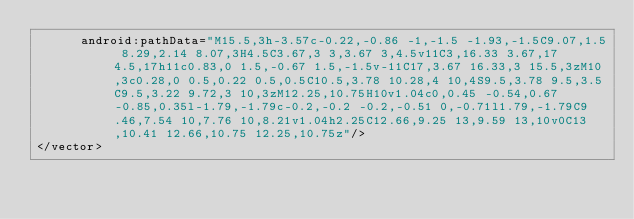<code> <loc_0><loc_0><loc_500><loc_500><_XML_>      android:pathData="M15.5,3h-3.57c-0.22,-0.86 -1,-1.5 -1.93,-1.5C9.07,1.5 8.29,2.14 8.07,3H4.5C3.67,3 3,3.67 3,4.5v11C3,16.33 3.67,17 4.5,17h11c0.83,0 1.5,-0.67 1.5,-1.5v-11C17,3.67 16.33,3 15.5,3zM10,3c0.28,0 0.5,0.22 0.5,0.5C10.5,3.78 10.28,4 10,4S9.5,3.78 9.5,3.5C9.5,3.22 9.72,3 10,3zM12.25,10.75H10v1.04c0,0.45 -0.54,0.67 -0.85,0.35l-1.79,-1.79c-0.2,-0.2 -0.2,-0.51 0,-0.71l1.79,-1.79C9.46,7.54 10,7.76 10,8.21v1.04h2.25C12.66,9.25 13,9.59 13,10v0C13,10.41 12.66,10.75 12.25,10.75z"/>
</vector>
</code> 